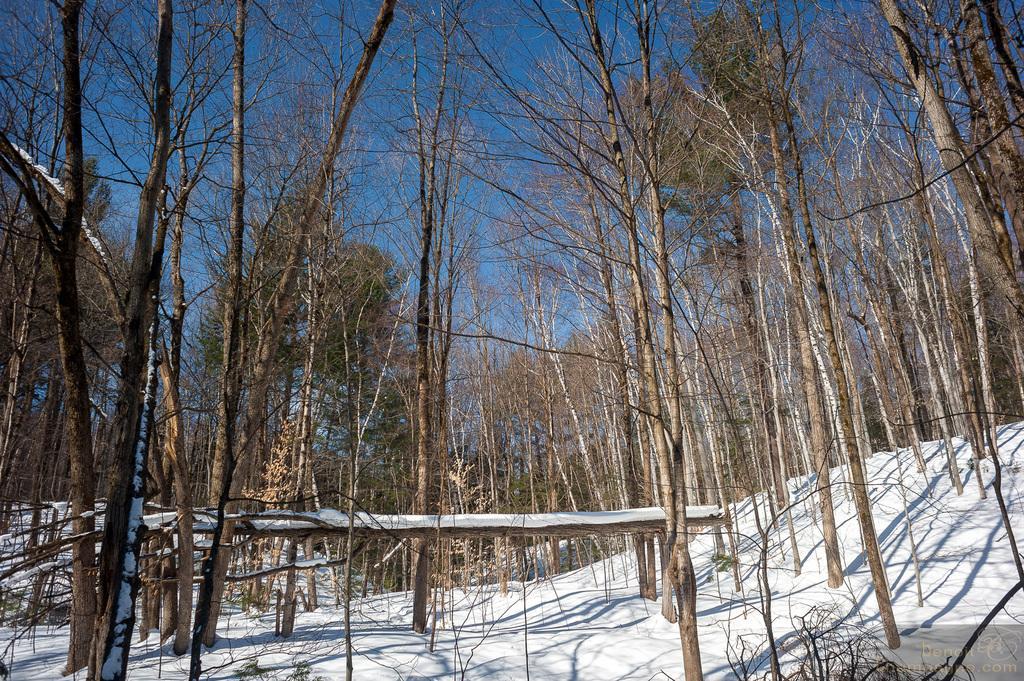Please provide a concise description of this image. In this image we can see sky, trees and snow. 